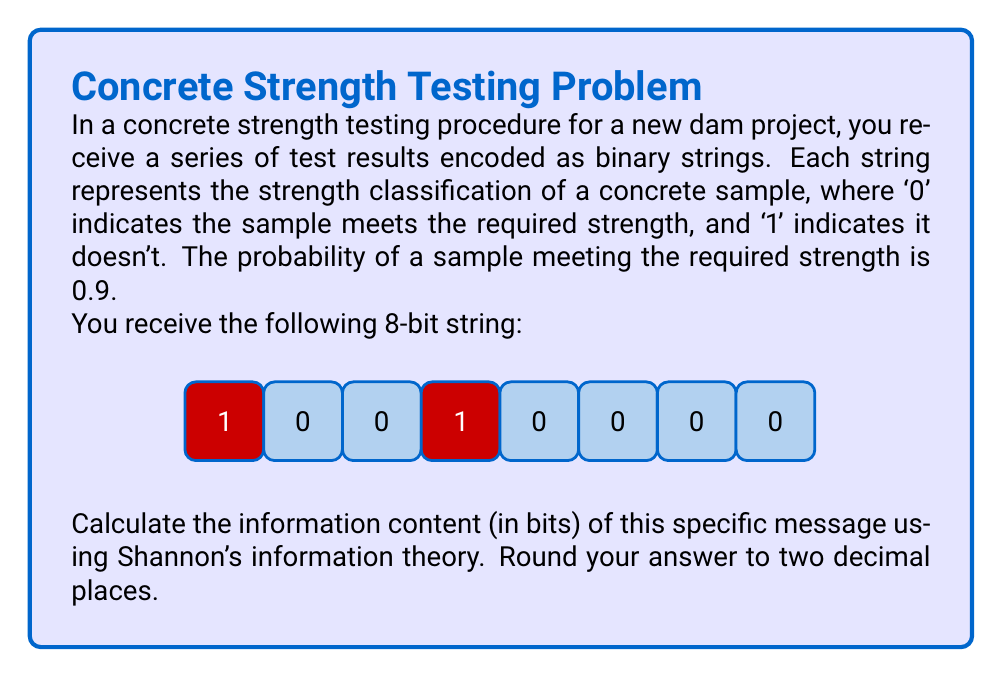Give your solution to this math problem. Let's approach this step-by-step using Shannon's information theory:

1) In information theory, the information content (I) of an event with probability p is given by:

   $$I = -\log_2(p)$$

2) In our case, we have two types of events:
   - '0': Sample meets required strength, p = 0.9
   - '1': Sample doesn't meet required strength, p = 1 - 0.9 = 0.1

3) Let's calculate the information content for each event:
   For '0': $$I_0 = -\log_2(0.9) = 0.152 \text{ bits}$$
   For '1': $$I_1 = -\log_2(0.1) = 3.322 \text{ bits}$$

4) Now, let's count the occurrences in our 8-bit string:
   - '0' appears 6 times
   - '1' appears 2 times

5) The total information content is the sum of the information from each bit:
   $$I_{total} = 6 \times I_0 + 2 \times I_1$$
   $$I_{total} = 6 \times 0.152 + 2 \times 3.322$$
   $$I_{total} = 0.912 + 6.644 = 7.556 \text{ bits}$$

6) Rounding to two decimal places:
   $$I_{total} \approx 7.56 \text{ bits}$$
Answer: 7.56 bits 